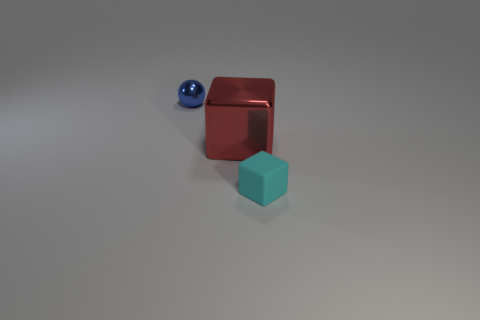Are there fewer small objects than large red blocks? Actually, it appears that there are an equal number of small objects and large red blocks in the image, with one small blue sphere and one large red cube visible. 